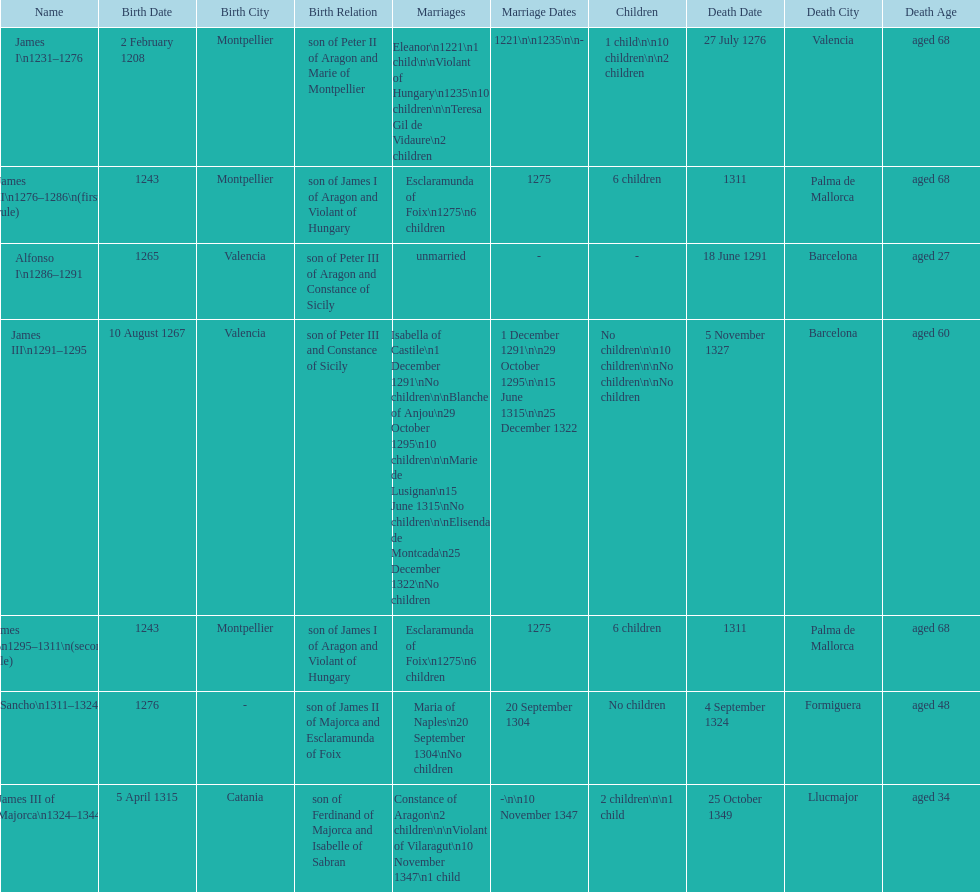Parse the table in full. {'header': ['Name', 'Birth Date', 'Birth City', 'Birth Relation', 'Marriages', 'Marriage Dates', 'Children', 'Death Date', 'Death City', 'Death Age'], 'rows': [['James I\\n1231–1276', '2 February 1208', 'Montpellier', 'son of Peter II of Aragon and Marie of Montpellier', 'Eleanor\\n1221\\n1 child\\n\\nViolant of Hungary\\n1235\\n10 children\\n\\nTeresa Gil de Vidaure\\n2 children', '1221\\n\\n1235\\n\\n-', '1 child\\n\\n10 children\\n\\n2 children', '27 July 1276', 'Valencia', 'aged 68'], ['James II\\n1276–1286\\n(first rule)', '1243', 'Montpellier', 'son of James I of Aragon and Violant of Hungary', 'Esclaramunda of Foix\\n1275\\n6 children', '1275', '6 children', '1311', 'Palma de Mallorca', 'aged 68'], ['Alfonso I\\n1286–1291', '1265', 'Valencia', 'son of Peter III of Aragon and Constance of Sicily', 'unmarried', '-', '-', '18 June 1291', 'Barcelona', 'aged 27'], ['James III\\n1291–1295', '10 August 1267', 'Valencia', 'son of Peter III and Constance of Sicily', 'Isabella of Castile\\n1 December 1291\\nNo children\\n\\nBlanche of Anjou\\n29 October 1295\\n10 children\\n\\nMarie de Lusignan\\n15 June 1315\\nNo children\\n\\nElisenda de Montcada\\n25 December 1322\\nNo children', '1 December 1291\\n\\n29 October 1295\\n\\n15 June 1315\\n\\n25 December 1322', 'No children\\n\\n10 children\\n\\nNo children\\n\\nNo children', '5 November 1327', 'Barcelona', 'aged 60'], ['James II\\n1295–1311\\n(second rule)', '1243', 'Montpellier', 'son of James I of Aragon and Violant of Hungary', 'Esclaramunda of Foix\\n1275\\n6 children', '1275', '6 children', '1311', 'Palma de Mallorca', 'aged 68'], ['Sancho\\n1311–1324', '1276', '-', 'son of James II of Majorca and Esclaramunda of Foix', 'Maria of Naples\\n20 September 1304\\nNo children', '20 September 1304', 'No children', '4 September 1324', 'Formiguera', 'aged 48'], ['James III of Majorca\\n1324–1344', '5 April 1315', 'Catania', 'son of Ferdinand of Majorca and Isabelle of Sabran', 'Constance of Aragon\\n2 children\\n\\nViolant of Vilaragut\\n10 November 1347\\n1 child', '-\\n\\n10 November 1347', '2 children\\n\\n1 child', '25 October 1349', 'Llucmajor', 'aged 34']]} Which monarch had the most marriages? James III 1291-1295. 